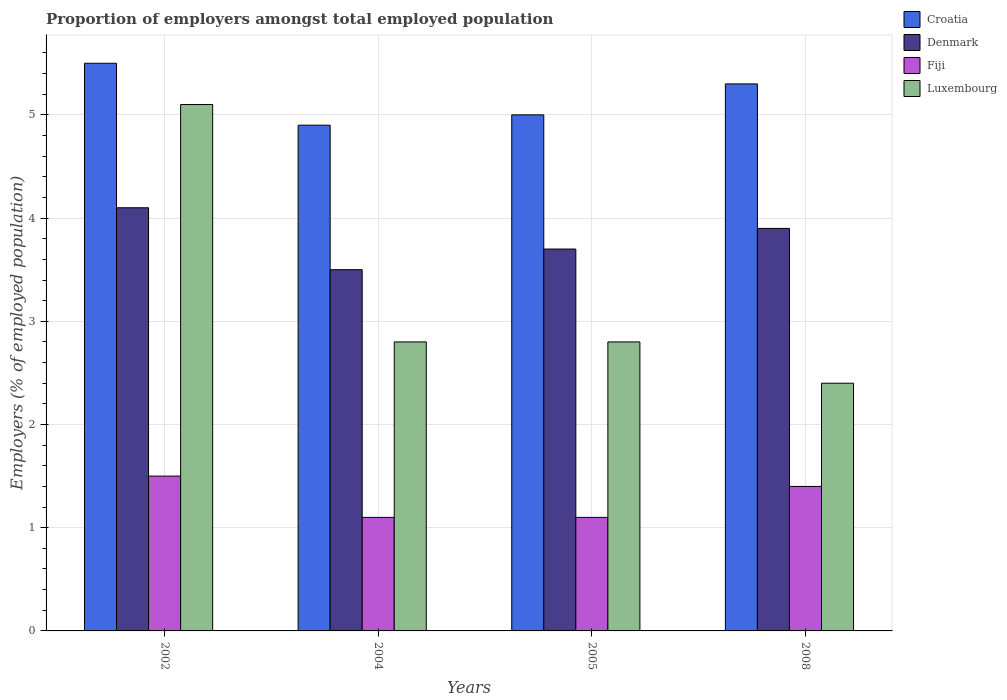How many groups of bars are there?
Your answer should be compact. 4. Are the number of bars per tick equal to the number of legend labels?
Provide a succinct answer. Yes. Are the number of bars on each tick of the X-axis equal?
Give a very brief answer. Yes. How many bars are there on the 1st tick from the left?
Your response must be concise. 4. In how many cases, is the number of bars for a given year not equal to the number of legend labels?
Make the answer very short. 0. What is the proportion of employers in Luxembourg in 2005?
Ensure brevity in your answer.  2.8. Across all years, what is the maximum proportion of employers in Fiji?
Make the answer very short. 1.5. Across all years, what is the minimum proportion of employers in Fiji?
Offer a very short reply. 1.1. What is the total proportion of employers in Luxembourg in the graph?
Your answer should be compact. 13.1. What is the difference between the proportion of employers in Croatia in 2002 and that in 2004?
Give a very brief answer. 0.6. What is the difference between the proportion of employers in Fiji in 2008 and the proportion of employers in Croatia in 2002?
Your answer should be compact. -4.1. What is the average proportion of employers in Croatia per year?
Your answer should be compact. 5.18. In the year 2002, what is the difference between the proportion of employers in Croatia and proportion of employers in Denmark?
Your answer should be compact. 1.4. In how many years, is the proportion of employers in Fiji greater than 4.6 %?
Provide a short and direct response. 0. What is the ratio of the proportion of employers in Croatia in 2004 to that in 2005?
Your answer should be compact. 0.98. Is the proportion of employers in Denmark in 2004 less than that in 2008?
Provide a succinct answer. Yes. What is the difference between the highest and the second highest proportion of employers in Denmark?
Offer a terse response. 0.2. What is the difference between the highest and the lowest proportion of employers in Fiji?
Ensure brevity in your answer.  0.4. In how many years, is the proportion of employers in Denmark greater than the average proportion of employers in Denmark taken over all years?
Ensure brevity in your answer.  2. Is the sum of the proportion of employers in Croatia in 2002 and 2004 greater than the maximum proportion of employers in Denmark across all years?
Ensure brevity in your answer.  Yes. What does the 4th bar from the left in 2005 represents?
Provide a short and direct response. Luxembourg. What does the 1st bar from the right in 2002 represents?
Offer a terse response. Luxembourg. How many years are there in the graph?
Offer a very short reply. 4. How many legend labels are there?
Your answer should be compact. 4. What is the title of the graph?
Keep it short and to the point. Proportion of employers amongst total employed population. What is the label or title of the Y-axis?
Your answer should be very brief. Employers (% of employed population). What is the Employers (% of employed population) in Denmark in 2002?
Your answer should be very brief. 4.1. What is the Employers (% of employed population) of Fiji in 2002?
Your response must be concise. 1.5. What is the Employers (% of employed population) of Luxembourg in 2002?
Ensure brevity in your answer.  5.1. What is the Employers (% of employed population) of Croatia in 2004?
Offer a terse response. 4.9. What is the Employers (% of employed population) of Denmark in 2004?
Your answer should be very brief. 3.5. What is the Employers (% of employed population) of Fiji in 2004?
Offer a very short reply. 1.1. What is the Employers (% of employed population) in Luxembourg in 2004?
Give a very brief answer. 2.8. What is the Employers (% of employed population) of Denmark in 2005?
Make the answer very short. 3.7. What is the Employers (% of employed population) of Fiji in 2005?
Provide a succinct answer. 1.1. What is the Employers (% of employed population) in Luxembourg in 2005?
Give a very brief answer. 2.8. What is the Employers (% of employed population) in Croatia in 2008?
Offer a terse response. 5.3. What is the Employers (% of employed population) in Denmark in 2008?
Your response must be concise. 3.9. What is the Employers (% of employed population) in Fiji in 2008?
Keep it short and to the point. 1.4. What is the Employers (% of employed population) of Luxembourg in 2008?
Make the answer very short. 2.4. Across all years, what is the maximum Employers (% of employed population) in Croatia?
Your answer should be very brief. 5.5. Across all years, what is the maximum Employers (% of employed population) in Denmark?
Keep it short and to the point. 4.1. Across all years, what is the maximum Employers (% of employed population) in Fiji?
Offer a very short reply. 1.5. Across all years, what is the maximum Employers (% of employed population) in Luxembourg?
Give a very brief answer. 5.1. Across all years, what is the minimum Employers (% of employed population) in Croatia?
Keep it short and to the point. 4.9. Across all years, what is the minimum Employers (% of employed population) in Fiji?
Your response must be concise. 1.1. Across all years, what is the minimum Employers (% of employed population) of Luxembourg?
Make the answer very short. 2.4. What is the total Employers (% of employed population) in Croatia in the graph?
Provide a succinct answer. 20.7. What is the difference between the Employers (% of employed population) in Croatia in 2002 and that in 2004?
Ensure brevity in your answer.  0.6. What is the difference between the Employers (% of employed population) in Fiji in 2002 and that in 2004?
Your answer should be compact. 0.4. What is the difference between the Employers (% of employed population) of Croatia in 2002 and that in 2005?
Make the answer very short. 0.5. What is the difference between the Employers (% of employed population) of Denmark in 2002 and that in 2005?
Provide a succinct answer. 0.4. What is the difference between the Employers (% of employed population) in Fiji in 2002 and that in 2005?
Ensure brevity in your answer.  0.4. What is the difference between the Employers (% of employed population) in Luxembourg in 2002 and that in 2005?
Offer a terse response. 2.3. What is the difference between the Employers (% of employed population) in Croatia in 2002 and that in 2008?
Provide a short and direct response. 0.2. What is the difference between the Employers (% of employed population) of Denmark in 2002 and that in 2008?
Ensure brevity in your answer.  0.2. What is the difference between the Employers (% of employed population) of Fiji in 2002 and that in 2008?
Keep it short and to the point. 0.1. What is the difference between the Employers (% of employed population) of Denmark in 2004 and that in 2005?
Keep it short and to the point. -0.2. What is the difference between the Employers (% of employed population) in Fiji in 2004 and that in 2005?
Your answer should be very brief. 0. What is the difference between the Employers (% of employed population) of Croatia in 2004 and that in 2008?
Keep it short and to the point. -0.4. What is the difference between the Employers (% of employed population) of Denmark in 2004 and that in 2008?
Your response must be concise. -0.4. What is the difference between the Employers (% of employed population) of Fiji in 2004 and that in 2008?
Provide a succinct answer. -0.3. What is the difference between the Employers (% of employed population) in Luxembourg in 2004 and that in 2008?
Your answer should be compact. 0.4. What is the difference between the Employers (% of employed population) of Croatia in 2005 and that in 2008?
Your response must be concise. -0.3. What is the difference between the Employers (% of employed population) of Fiji in 2005 and that in 2008?
Your response must be concise. -0.3. What is the difference between the Employers (% of employed population) of Luxembourg in 2005 and that in 2008?
Offer a very short reply. 0.4. What is the difference between the Employers (% of employed population) in Croatia in 2002 and the Employers (% of employed population) in Denmark in 2004?
Offer a terse response. 2. What is the difference between the Employers (% of employed population) of Denmark in 2002 and the Employers (% of employed population) of Fiji in 2004?
Provide a succinct answer. 3. What is the difference between the Employers (% of employed population) of Denmark in 2002 and the Employers (% of employed population) of Luxembourg in 2004?
Provide a succinct answer. 1.3. What is the difference between the Employers (% of employed population) in Fiji in 2002 and the Employers (% of employed population) in Luxembourg in 2004?
Make the answer very short. -1.3. What is the difference between the Employers (% of employed population) in Denmark in 2002 and the Employers (% of employed population) in Fiji in 2005?
Your response must be concise. 3. What is the difference between the Employers (% of employed population) of Croatia in 2002 and the Employers (% of employed population) of Denmark in 2008?
Offer a terse response. 1.6. What is the difference between the Employers (% of employed population) in Croatia in 2002 and the Employers (% of employed population) in Fiji in 2008?
Provide a short and direct response. 4.1. What is the difference between the Employers (% of employed population) in Denmark in 2002 and the Employers (% of employed population) in Fiji in 2008?
Offer a terse response. 2.7. What is the difference between the Employers (% of employed population) of Fiji in 2002 and the Employers (% of employed population) of Luxembourg in 2008?
Make the answer very short. -0.9. What is the difference between the Employers (% of employed population) of Croatia in 2004 and the Employers (% of employed population) of Denmark in 2005?
Give a very brief answer. 1.2. What is the difference between the Employers (% of employed population) in Croatia in 2004 and the Employers (% of employed population) in Luxembourg in 2005?
Give a very brief answer. 2.1. What is the difference between the Employers (% of employed population) of Denmark in 2004 and the Employers (% of employed population) of Luxembourg in 2005?
Ensure brevity in your answer.  0.7. What is the difference between the Employers (% of employed population) in Croatia in 2004 and the Employers (% of employed population) in Denmark in 2008?
Your answer should be compact. 1. What is the difference between the Employers (% of employed population) in Croatia in 2004 and the Employers (% of employed population) in Fiji in 2008?
Provide a short and direct response. 3.5. What is the difference between the Employers (% of employed population) of Croatia in 2004 and the Employers (% of employed population) of Luxembourg in 2008?
Ensure brevity in your answer.  2.5. What is the difference between the Employers (% of employed population) of Denmark in 2004 and the Employers (% of employed population) of Fiji in 2008?
Your answer should be very brief. 2.1. What is the difference between the Employers (% of employed population) in Croatia in 2005 and the Employers (% of employed population) in Denmark in 2008?
Provide a succinct answer. 1.1. What is the difference between the Employers (% of employed population) of Croatia in 2005 and the Employers (% of employed population) of Luxembourg in 2008?
Your answer should be very brief. 2.6. What is the average Employers (% of employed population) of Croatia per year?
Offer a terse response. 5.17. What is the average Employers (% of employed population) in Denmark per year?
Provide a short and direct response. 3.8. What is the average Employers (% of employed population) in Fiji per year?
Provide a short and direct response. 1.27. What is the average Employers (% of employed population) in Luxembourg per year?
Your answer should be very brief. 3.27. In the year 2002, what is the difference between the Employers (% of employed population) in Croatia and Employers (% of employed population) in Denmark?
Your answer should be very brief. 1.4. In the year 2002, what is the difference between the Employers (% of employed population) of Croatia and Employers (% of employed population) of Fiji?
Ensure brevity in your answer.  4. In the year 2002, what is the difference between the Employers (% of employed population) in Croatia and Employers (% of employed population) in Luxembourg?
Offer a very short reply. 0.4. In the year 2002, what is the difference between the Employers (% of employed population) of Denmark and Employers (% of employed population) of Luxembourg?
Offer a very short reply. -1. In the year 2002, what is the difference between the Employers (% of employed population) of Fiji and Employers (% of employed population) of Luxembourg?
Your response must be concise. -3.6. In the year 2004, what is the difference between the Employers (% of employed population) in Denmark and Employers (% of employed population) in Fiji?
Provide a short and direct response. 2.4. In the year 2004, what is the difference between the Employers (% of employed population) of Fiji and Employers (% of employed population) of Luxembourg?
Ensure brevity in your answer.  -1.7. In the year 2005, what is the difference between the Employers (% of employed population) of Croatia and Employers (% of employed population) of Denmark?
Offer a terse response. 1.3. In the year 2005, what is the difference between the Employers (% of employed population) in Croatia and Employers (% of employed population) in Fiji?
Your answer should be very brief. 3.9. In the year 2005, what is the difference between the Employers (% of employed population) of Fiji and Employers (% of employed population) of Luxembourg?
Your response must be concise. -1.7. In the year 2008, what is the difference between the Employers (% of employed population) in Croatia and Employers (% of employed population) in Denmark?
Your answer should be very brief. 1.4. In the year 2008, what is the difference between the Employers (% of employed population) of Croatia and Employers (% of employed population) of Fiji?
Your answer should be very brief. 3.9. In the year 2008, what is the difference between the Employers (% of employed population) of Croatia and Employers (% of employed population) of Luxembourg?
Your answer should be compact. 2.9. In the year 2008, what is the difference between the Employers (% of employed population) of Denmark and Employers (% of employed population) of Luxembourg?
Ensure brevity in your answer.  1.5. In the year 2008, what is the difference between the Employers (% of employed population) in Fiji and Employers (% of employed population) in Luxembourg?
Keep it short and to the point. -1. What is the ratio of the Employers (% of employed population) of Croatia in 2002 to that in 2004?
Offer a very short reply. 1.12. What is the ratio of the Employers (% of employed population) in Denmark in 2002 to that in 2004?
Your response must be concise. 1.17. What is the ratio of the Employers (% of employed population) of Fiji in 2002 to that in 2004?
Offer a terse response. 1.36. What is the ratio of the Employers (% of employed population) in Luxembourg in 2002 to that in 2004?
Your answer should be very brief. 1.82. What is the ratio of the Employers (% of employed population) in Croatia in 2002 to that in 2005?
Your answer should be very brief. 1.1. What is the ratio of the Employers (% of employed population) of Denmark in 2002 to that in 2005?
Offer a very short reply. 1.11. What is the ratio of the Employers (% of employed population) of Fiji in 2002 to that in 2005?
Ensure brevity in your answer.  1.36. What is the ratio of the Employers (% of employed population) of Luxembourg in 2002 to that in 2005?
Offer a very short reply. 1.82. What is the ratio of the Employers (% of employed population) of Croatia in 2002 to that in 2008?
Keep it short and to the point. 1.04. What is the ratio of the Employers (% of employed population) of Denmark in 2002 to that in 2008?
Provide a short and direct response. 1.05. What is the ratio of the Employers (% of employed population) in Fiji in 2002 to that in 2008?
Offer a terse response. 1.07. What is the ratio of the Employers (% of employed population) of Luxembourg in 2002 to that in 2008?
Provide a succinct answer. 2.12. What is the ratio of the Employers (% of employed population) in Denmark in 2004 to that in 2005?
Offer a terse response. 0.95. What is the ratio of the Employers (% of employed population) of Croatia in 2004 to that in 2008?
Your answer should be very brief. 0.92. What is the ratio of the Employers (% of employed population) of Denmark in 2004 to that in 2008?
Ensure brevity in your answer.  0.9. What is the ratio of the Employers (% of employed population) of Fiji in 2004 to that in 2008?
Provide a short and direct response. 0.79. What is the ratio of the Employers (% of employed population) in Croatia in 2005 to that in 2008?
Your answer should be very brief. 0.94. What is the ratio of the Employers (% of employed population) in Denmark in 2005 to that in 2008?
Make the answer very short. 0.95. What is the ratio of the Employers (% of employed population) in Fiji in 2005 to that in 2008?
Provide a succinct answer. 0.79. What is the ratio of the Employers (% of employed population) in Luxembourg in 2005 to that in 2008?
Offer a terse response. 1.17. What is the difference between the highest and the second highest Employers (% of employed population) in Croatia?
Your response must be concise. 0.2. What is the difference between the highest and the second highest Employers (% of employed population) in Denmark?
Offer a terse response. 0.2. What is the difference between the highest and the second highest Employers (% of employed population) of Fiji?
Ensure brevity in your answer.  0.1. What is the difference between the highest and the second highest Employers (% of employed population) of Luxembourg?
Offer a very short reply. 2.3. What is the difference between the highest and the lowest Employers (% of employed population) in Croatia?
Provide a short and direct response. 0.6. 